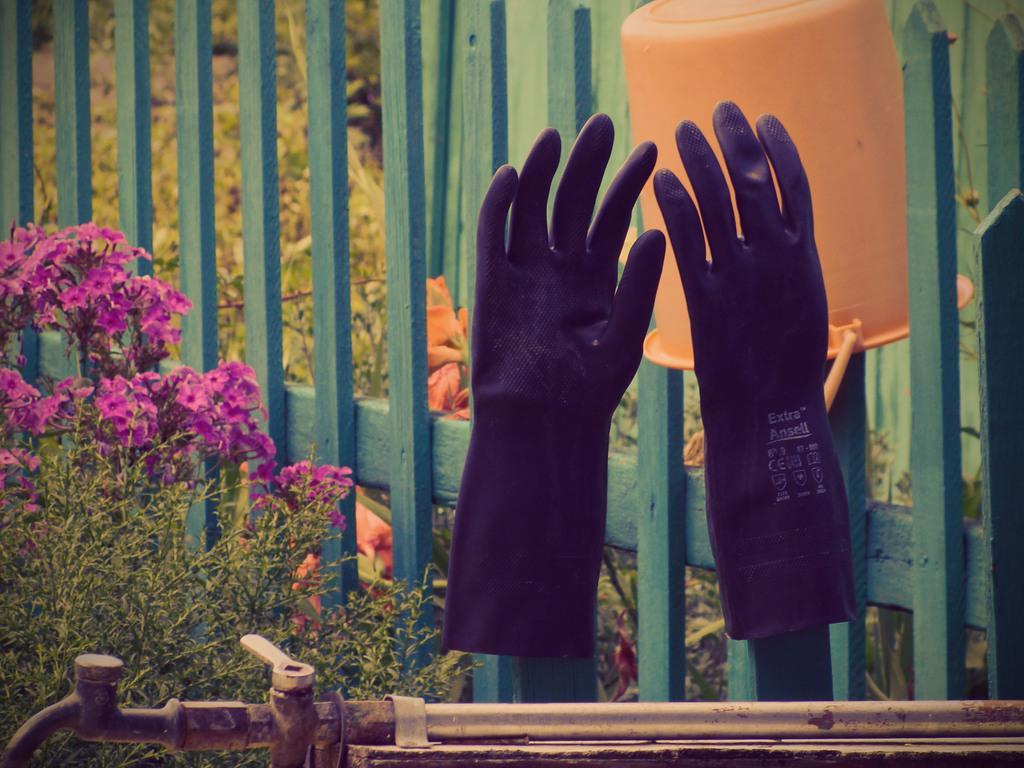Please provide a concise description of this image. Here we can see two gloves on two wooden poles. In the background there is a fence,plants with flowers and trees and there is a bucket on the wooden pole. At the bottom there is a tap and pipe. 